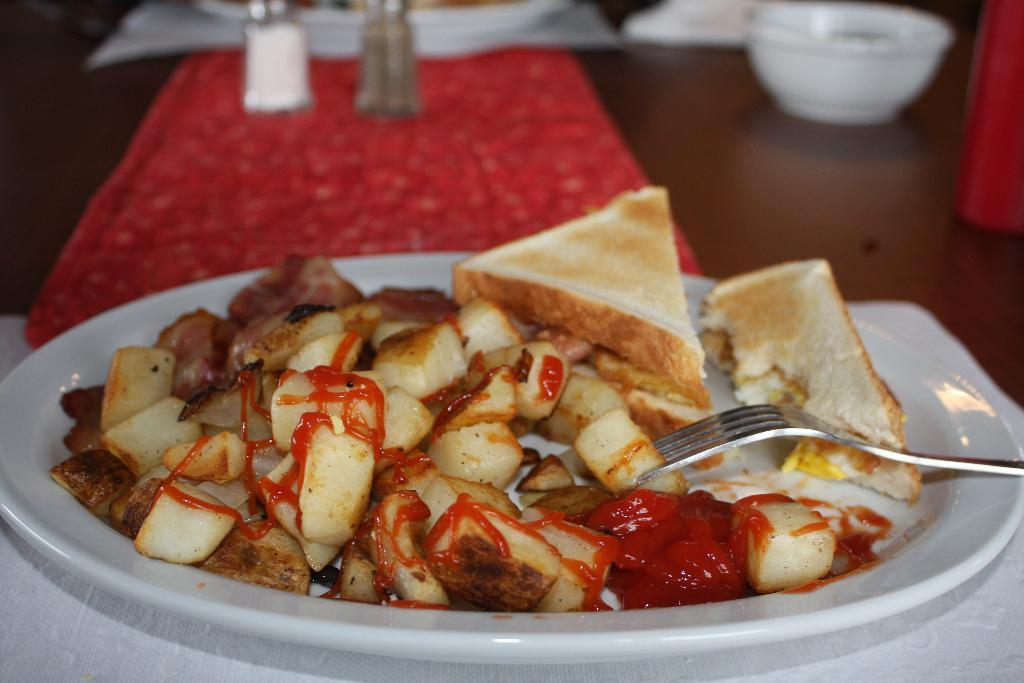What piece of furniture is present in the image? There is a table in the image. What is on top of the table? There is a bowl, plates, sprinklers, a napkin, and a fork on the table. What might be used for cleaning or wiping in the image? A napkin is present on the table for cleaning or wiping. What is placed on the table that might be used for eating? There is a fork on the table that might be used for eating. What is placed on the table that might contain food? There is a bowl on the table that might contain food. What is placed on the table that might be used for decoration or flavoring? There are sprinklers on the table that might be used for decoration or flavoring. Are there any toys visible on the table in the image? No, there are no toys visible on the table in the image. Are there any children present in the image? No, there is no mention of children in the provided facts, and no children are visible in the image. 